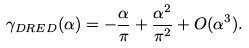Convert formula to latex. <formula><loc_0><loc_0><loc_500><loc_500>\gamma _ { D R E D } ( \alpha ) = - \frac { \alpha } { \pi } + \frac { \alpha ^ { 2 } } { \pi ^ { 2 } } + O ( \alpha ^ { 3 } ) .</formula> 